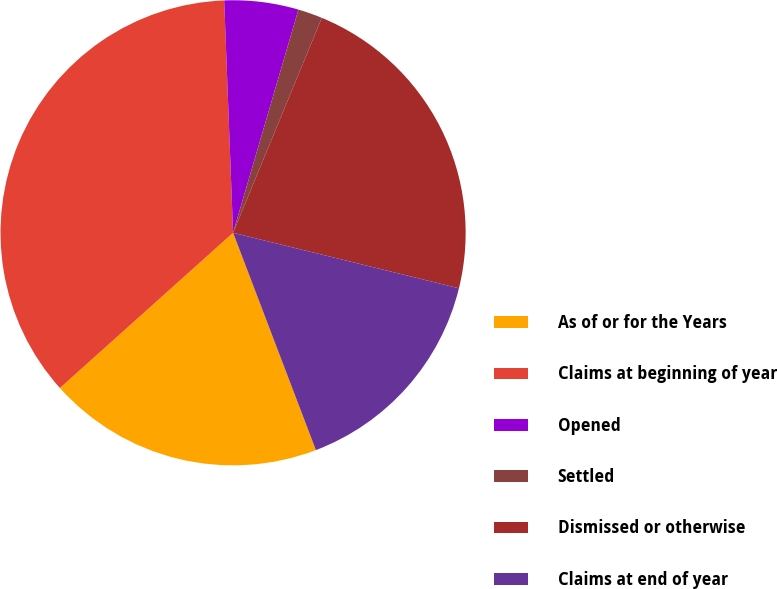Convert chart. <chart><loc_0><loc_0><loc_500><loc_500><pie_chart><fcel>As of or for the Years<fcel>Claims at beginning of year<fcel>Opened<fcel>Settled<fcel>Dismissed or otherwise<fcel>Claims at end of year<nl><fcel>19.16%<fcel>36.02%<fcel>5.14%<fcel>1.7%<fcel>22.6%<fcel>15.37%<nl></chart> 